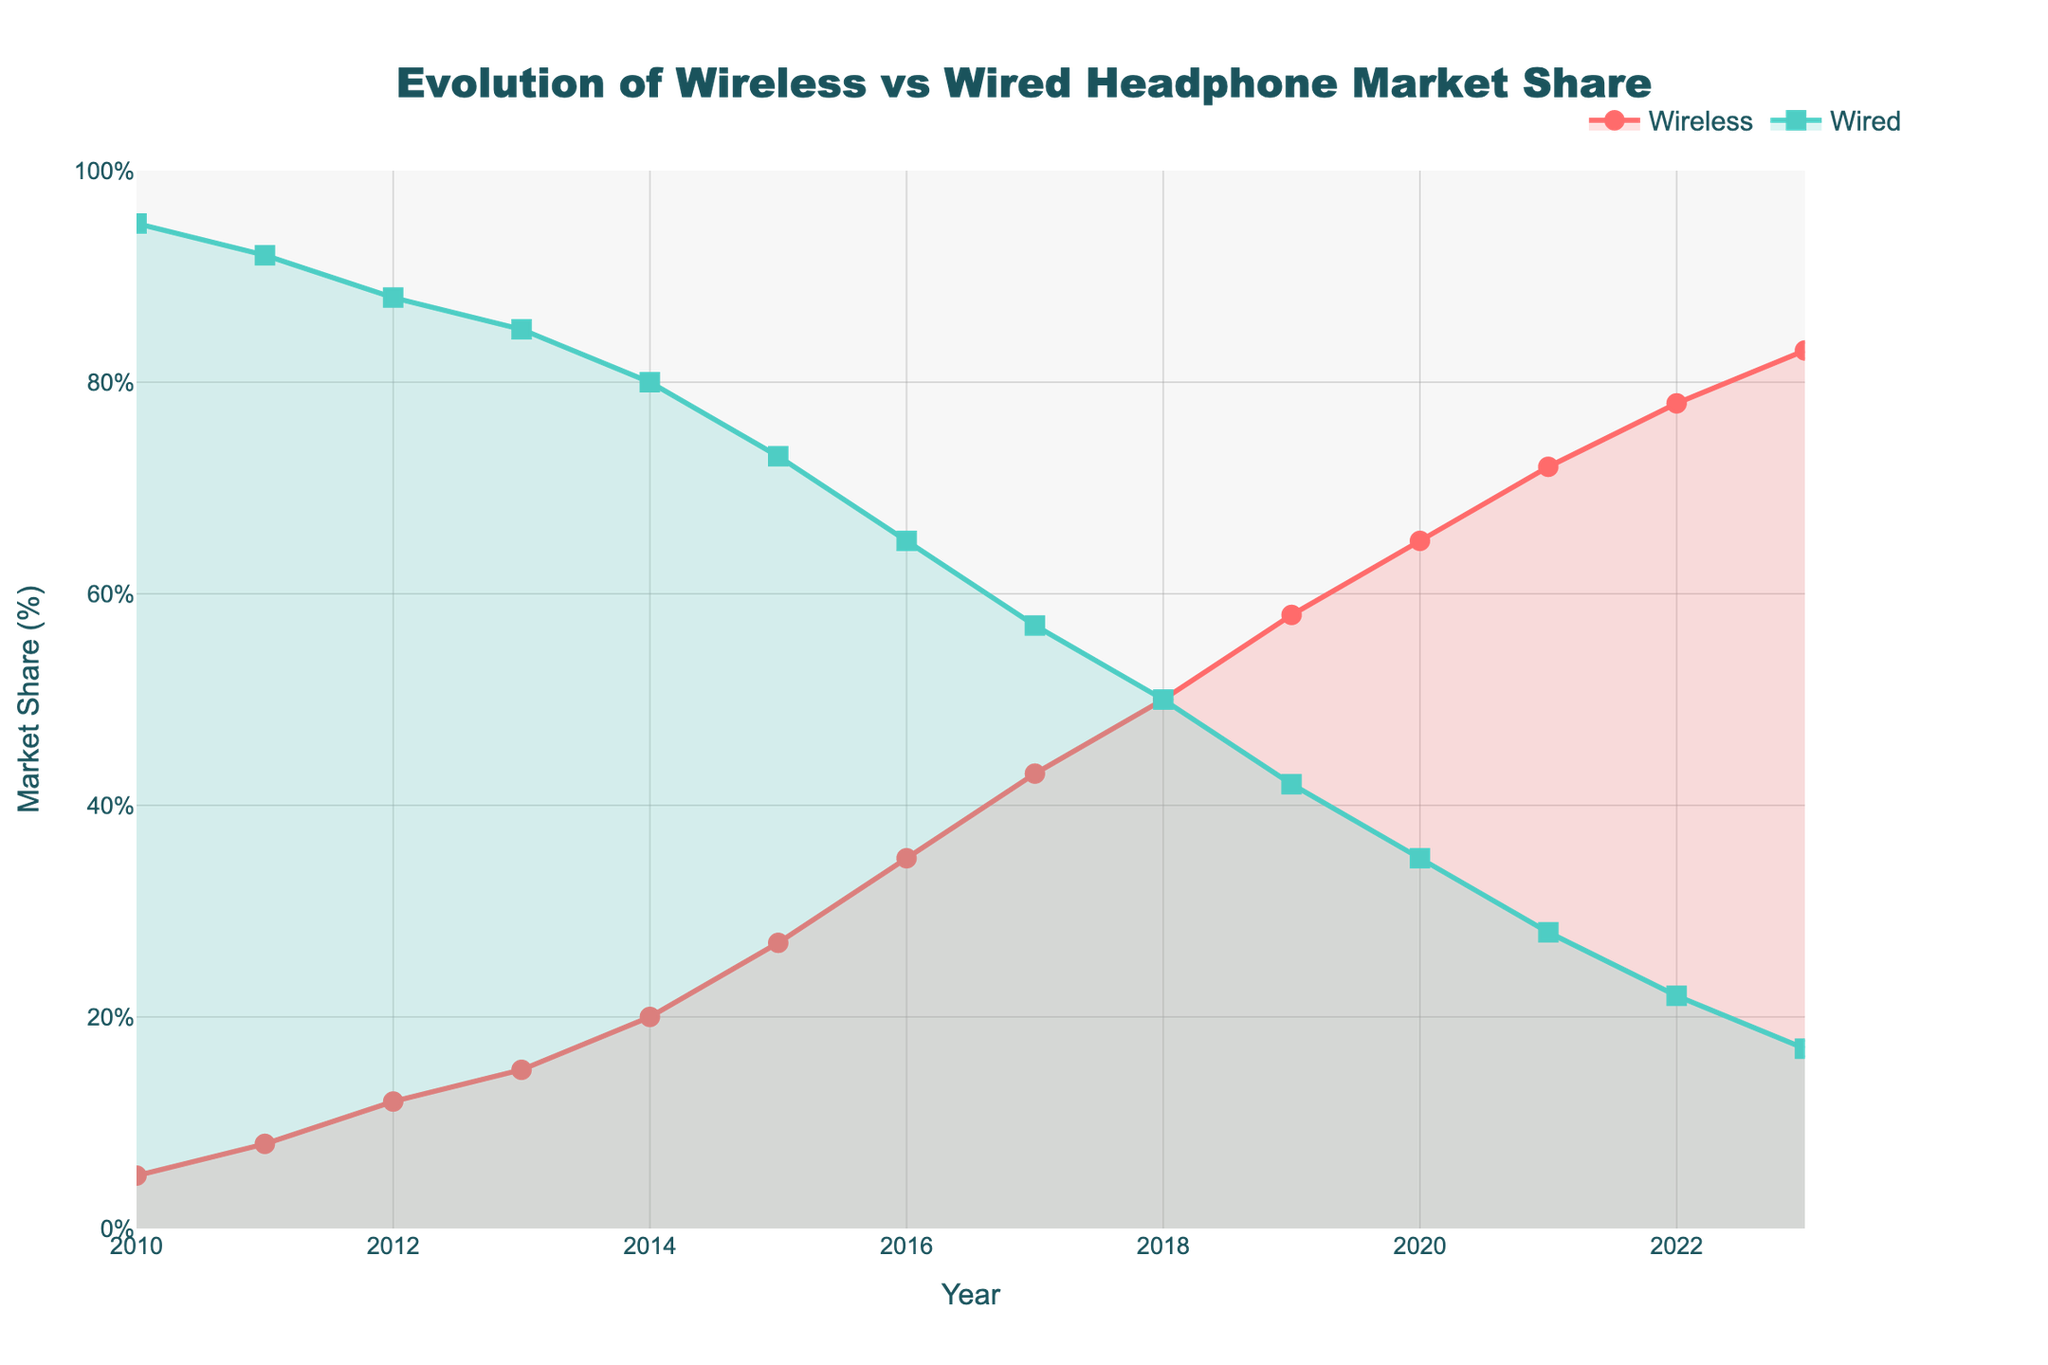What is the title of the plot? The title of the plot can be found at the top of the figure and summarizes the main topic of the plot.
Answer: Evolution of Wireless vs Wired Headphone Market Share What is the range of years displayed on the x-axis? Look at the x-axis at the bottom of the plot which shows the range of years.
Answer: 2010 to 2023 What is the market share of wireless headphones in 2015? Locate the year 2015 on the x-axis, then find the corresponding market share for wireless headphones from the plot.
Answer: 27% What color is used to represent wired headphone market share? Examine the color of the line and markers that denote wired headphone market share.
Answer: Green How is the y-axis labeled? The y-axis label is displayed on the left side of the plot, indicating the measurement unit.
Answer: Market Share (%) What is the total market share for both wireless and wired headphones in 2018? Add the market shares of wireless and wired headphones for the year 2018 by locating the data point for that year.
Answer: 50% + 50% = 100% What is the average market share of wireless headphones from 2010 to 2023? Sum up the market shares of wireless headphones from 2010 to 2023 and then divide by the number of years (14).
Answer: (5 + 8 + 12 + 15 + 20 + 27 + 35 + 43 + 50 + 58 + 65 + 72 + 78 + 83) / 14 = 43.86% By how much did the market share of wired headphones decrease from 2010 to 2023? Subtract the market share of wired headphones in 2023 from that in 2010 by locating the respective data points.
Answer: 95% - 17% = 78% What is the average annual increase in wireless headphone market share from 2010 to 2023? Subtract the market share of wireless headphones in 2010 from that in 2023, then divide by the number of years (13).
Answer: (83% - 5%) / 13 = 6% Which year did wireless headphones first reach a market share of over 50%? Find the year when the market share of wireless headphones crosses 50% for the first time by examining the plot.
Answer: 2018 In which year did wired headphones have the steepest decline in market share? Compare the declines in market share of wired headphones year by year to find the steepest drop.
Answer: 2015 (7%) Did wireless headphones ever have a lower market share than wired headphones after 2018? Examine the data points after 2018 to see if the market share of wireless headphones was ever lower than that of wired headphones.
Answer: No What is the overall trend of wireless headphone market share from 2010 to 2023? Look at the overall pattern and direction of the wireless headphone market share line from the start to the end of the plot.
Answer: Increasing How does the trend of wired headphone market share compare to that of wireless headphones? Compare the overall direction and pattern of the wired headphone market share line to the wireless headphone market share line over the years.
Answer: Decreasing 